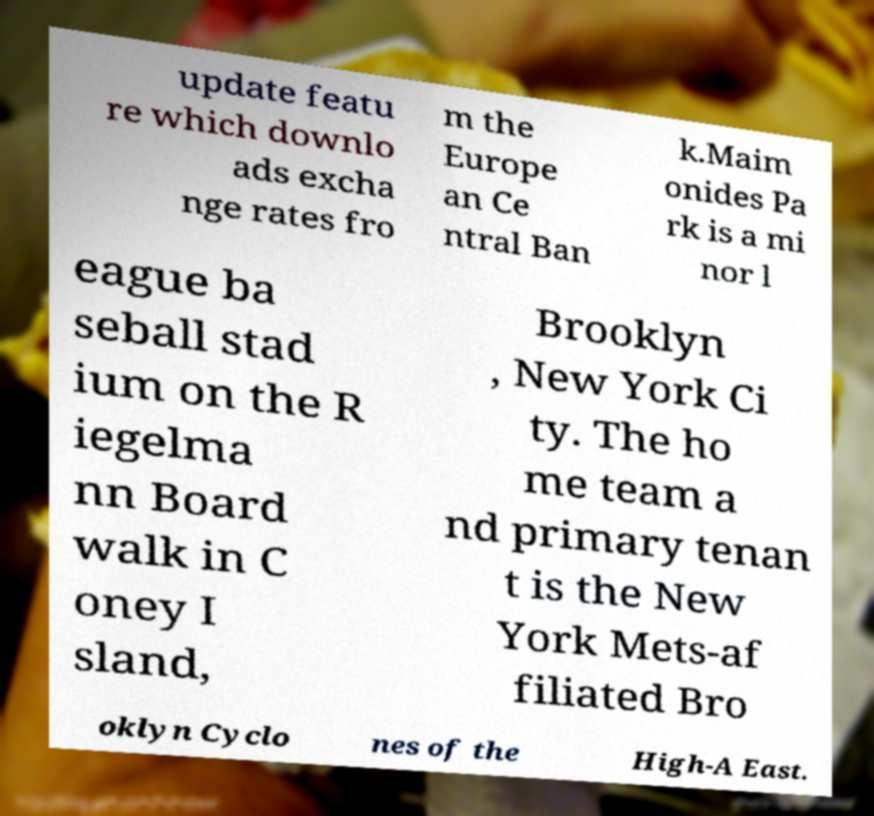Can you read and provide the text displayed in the image?This photo seems to have some interesting text. Can you extract and type it out for me? update featu re which downlo ads excha nge rates fro m the Europe an Ce ntral Ban k.Maim onides Pa rk is a mi nor l eague ba seball stad ium on the R iegelma nn Board walk in C oney I sland, Brooklyn , New York Ci ty. The ho me team a nd primary tenan t is the New York Mets-af filiated Bro oklyn Cyclo nes of the High-A East. 